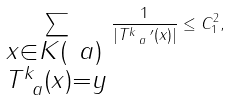<formula> <loc_0><loc_0><loc_500><loc_500>\sum _ { \begin{subarray} { c } x \in K ( \ a ) \\ T _ { \ a } ^ { k } ( x ) = y \end{subarray} } \frac { 1 } { | T _ { \ a } ^ { k } \, ^ { \prime } ( x ) | } \leq C _ { 1 } ^ { 2 } ,</formula> 